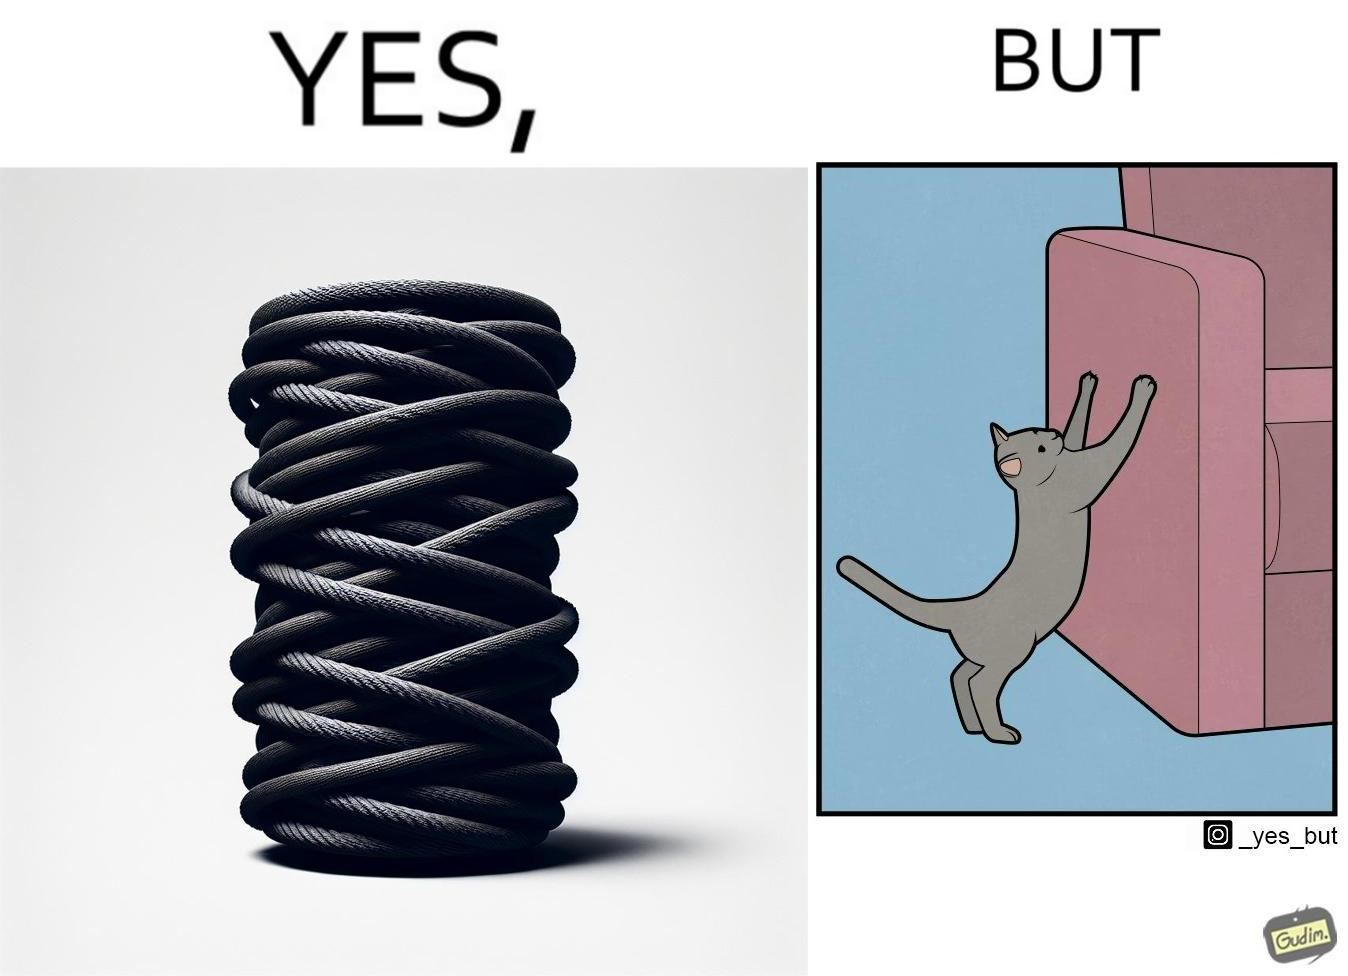Does this image contain satire or humor? Yes, this image is satirical. 